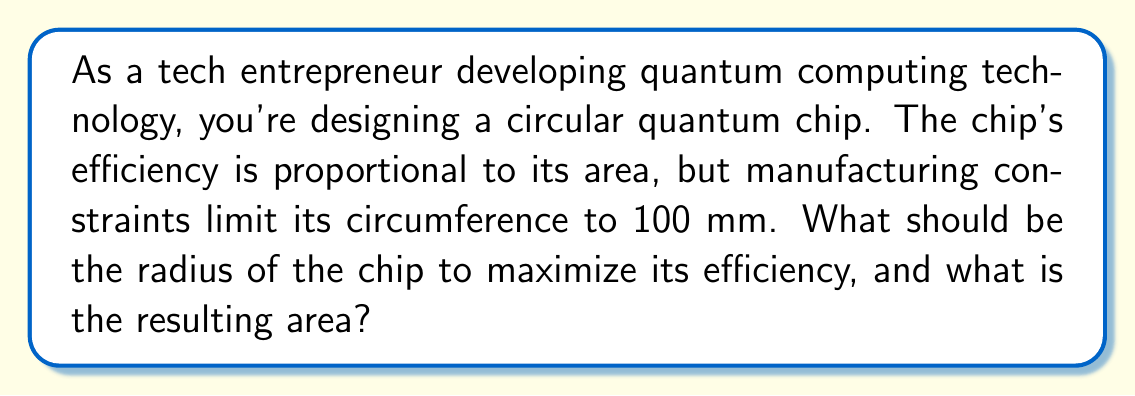Could you help me with this problem? To solve this problem, we need to maximize the area of a circle given a fixed circumference. Let's approach this step-by-step:

1) First, recall the formulas for circumference and area of a circle:
   Circumference: $C = 2\pi r$
   Area: $A = \pi r^2$

2) We're given that the circumference is 100 mm. Let's use this to express the radius:
   $100 = 2\pi r$
   $r = \frac{100}{2\pi} = \frac{50}{\pi}$

3) Now, we can express the area in terms of the circumference:
   $A = \pi r^2 = \pi (\frac{50}{\pi})^2 = \frac{2500}{\pi}$

4) To convert this to mm², we need to calculate the value:
   $A = \frac{2500}{\pi} \approx 795.77$ mm²

5) For the radius, we can calculate:
   $r = \frac{50}{\pi} \approx 15.92$ mm

This solution maximizes the area because we've used the entire allowed circumference to create the largest possible circle.

[asy]
import geometry;

unitsize(1mm);

pair O = (0,0);
real r = 15.92;
draw(circle(O, r), rgb(0,0,1));
draw(O--(-r,0), dashed);
label("r", (-r/2,0), S);
label("15.92 mm", (0,-r-2), N);

draw((-r-2,-r-2)--(r+2,-r-2)--(r+2,r+2)--(-r-2,r+2)--cycle);
label("31.84 mm", (0,r+4), S);
label("31.84 mm", (-r-4,0), E);
[/asy]
Answer: The optimal radius of the quantum chip is approximately 15.92 mm, resulting in a maximum area of about 795.77 mm². 